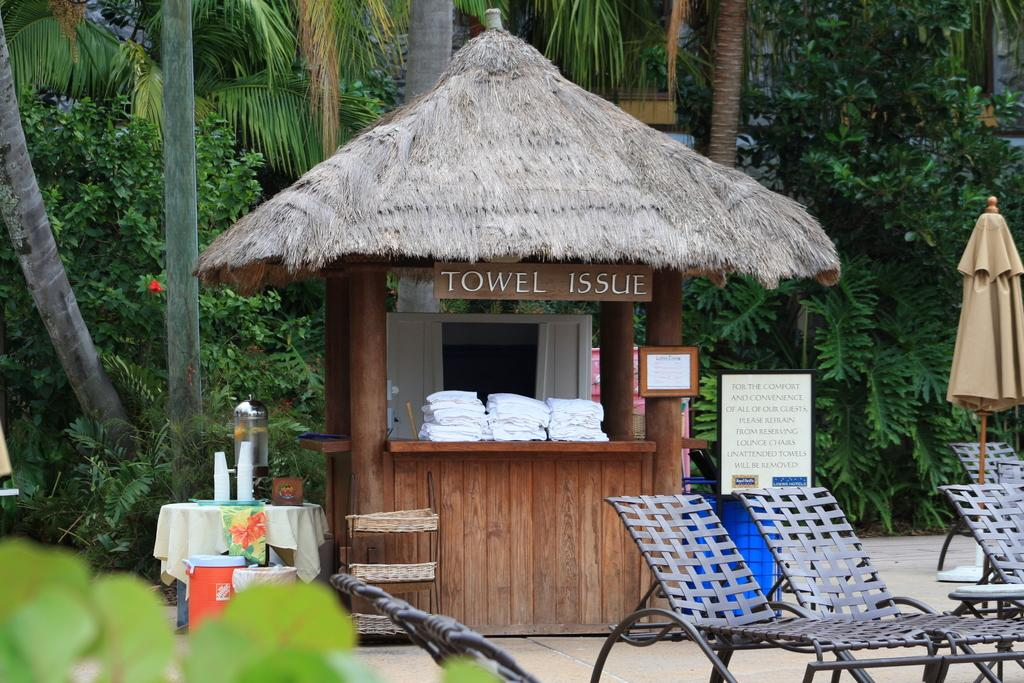What type of furniture is present in the image? There are chairs in the image. What can be seen hanging or displayed in the image? There is a banner in the image. What surface is visible in the image that might be used for placing objects? There is a table in the image. What type of receptacle is present in the image for disposing of waste? There are dustbins in the image. What type of natural vegetation is present in the image? There are trees in the image. What type of man-made structure is present in the image? There is a building in the image. Who is the creator of the dustbins in the image? There is no information about the creator of the dustbins in the image. Does the existence of the trees in the image imply that they can fold their branches? The trees in the image do not fold their branches; they are stationary and do not exhibit any movement or folding. 